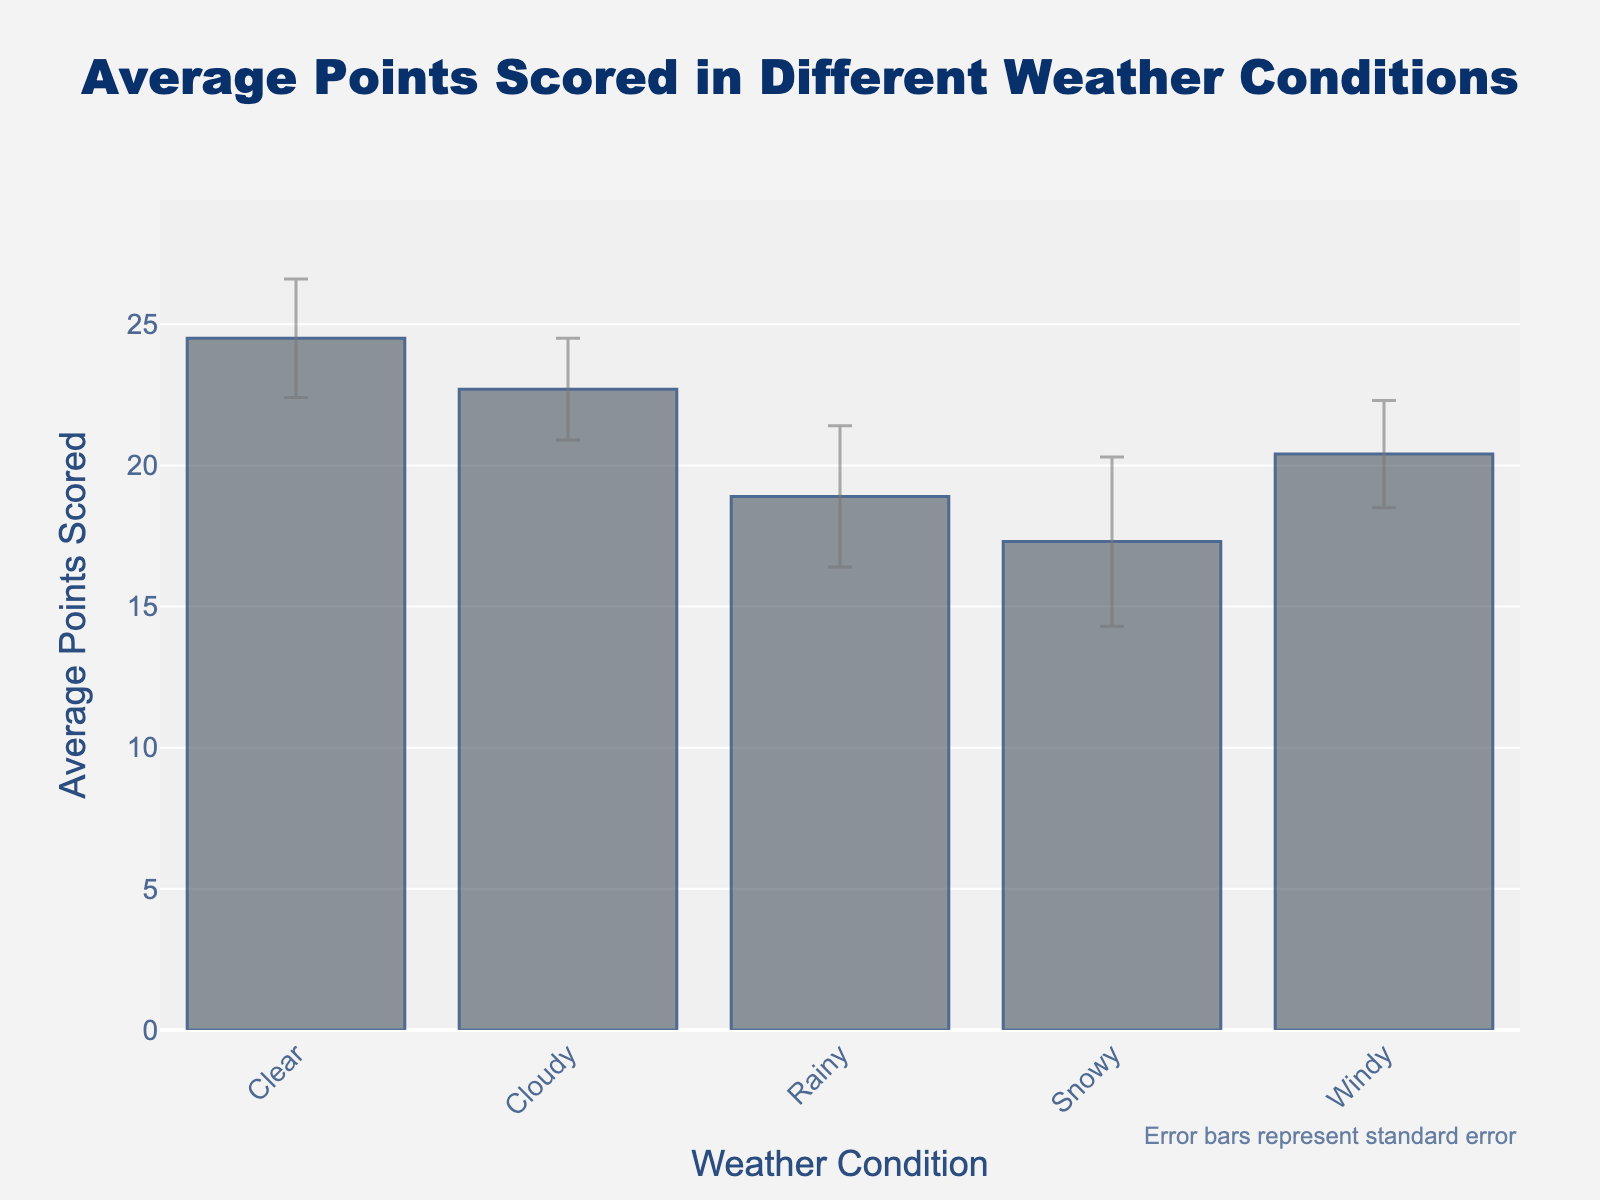what is the title of the figure? The title is generally located at the top of the figure and describes the overall content. In this case, it says "Average Points Scored in Different Weather Conditions".
Answer: Average Points Scored in Different Weather Conditions What does the y-axis represent in the figure? The y-axis title typically describes the vertical axis, which in this case indicates "Average Points Scored".
Answer: Average Points Scored Which weather condition has the highest average points scored? By visually inspecting the height of the bars in the figure, the bar representing the "Clear" weather condition is the tallest, indicating the highest average points scored.
Answer: Clear What is the average points scored for snowy conditions? The height of the bar corresponding to the "Snowy" weather condition indicates the average points scored, which is 17.3.
Answer: 17.3 How does the average points scored in rainy conditions compare to windy conditions? The average points scored in rainy conditions is 18.9, while for windy conditions it is 20.4. Comparing these values, we can see that the average points scored in windy conditions is higher than in rainy conditions.
Answer: Windy conditions have higher average points scored What is the range of average points scored across all weather conditions? The minimum average points scored is in "Snowy" conditions at 17.3, and the maximum is in "Clear" conditions at 24.5. The range is the difference: 24.5 - 17.3 = 7.2.
Answer: 7.2 Which weather condition has the largest standard error, and what does this indicate? By examining the error bars, the "Snowy" condition has the largest standard error of 3.0. This indicates that there is more variability or uncertainty in the average points scored for snowy conditions compared to others.
Answer: Snowy If you combine the average points scored for clear and cloudy weather, what is the total? The average points scored for clear weather is 24.5, and for cloudy weather, it is 22.7. Combined, the total is 24.5 + 22.7 = 47.2.
Answer: 47.2 What is the relative difference in average points scored between the clear and rainy conditions? The difference in average points scored between clear (24.5) and rainy (18.9) conditions is 24.5 - 18.9 = 5.6. To find the relative difference, (5.6 / 24.5) * 100 ≈ 22.9%.
Answer: 22.9% Which weather condition shows more uncertainty in the average points scored, clear or rainy? By comparing the lengths of the error bars, "Rainy" conditions show greater uncertainty with a standard error of 2.5, while "Clear" conditions have a standard error of 2.1.
Answer: Rainy 